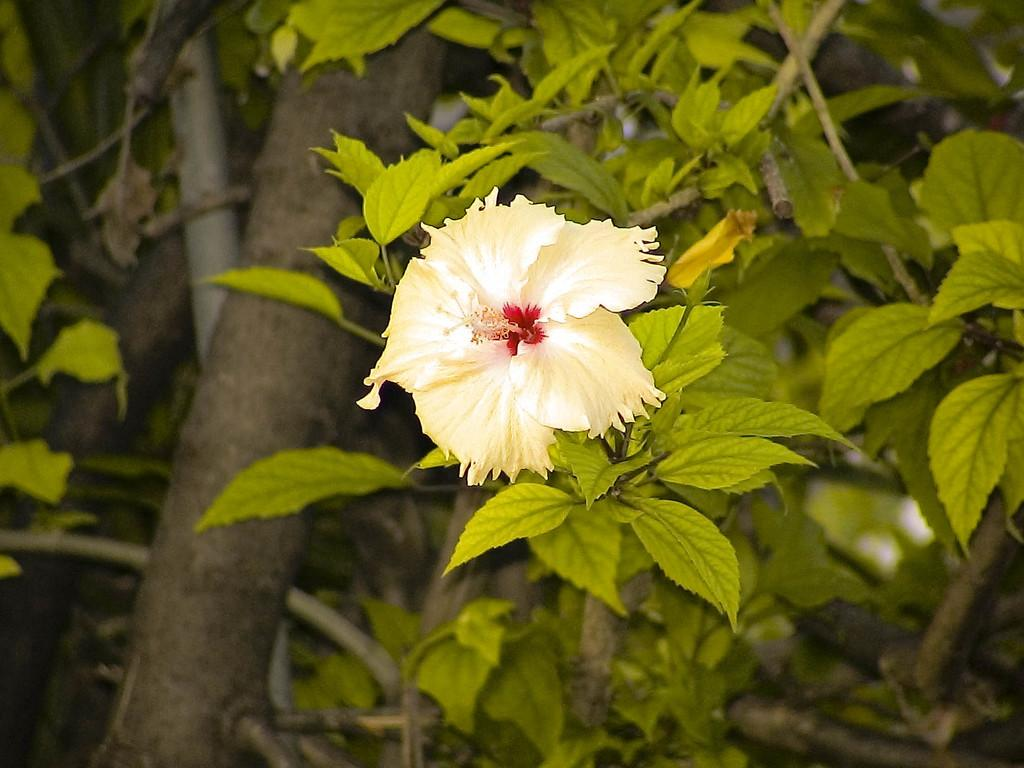What type of plant can be seen in the image? There is a flower on the branch of a tree in the image. Can you describe the location of the flower in the image? The flower is on the branch of a tree. What type of silk is used to make the flower in the image? There is no mention of silk or any fabric in the image; the flower is on a tree branch. 